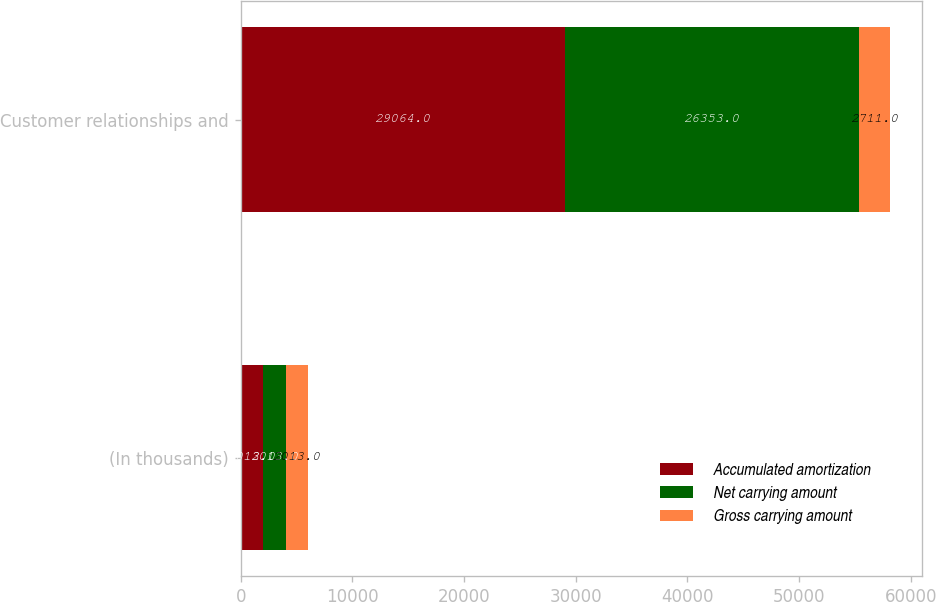<chart> <loc_0><loc_0><loc_500><loc_500><stacked_bar_chart><ecel><fcel>(In thousands)<fcel>Customer relationships and<nl><fcel>Accumulated amortization<fcel>2013<fcel>29064<nl><fcel>Net carrying amount<fcel>2013<fcel>26353<nl><fcel>Gross carrying amount<fcel>2013<fcel>2711<nl></chart> 